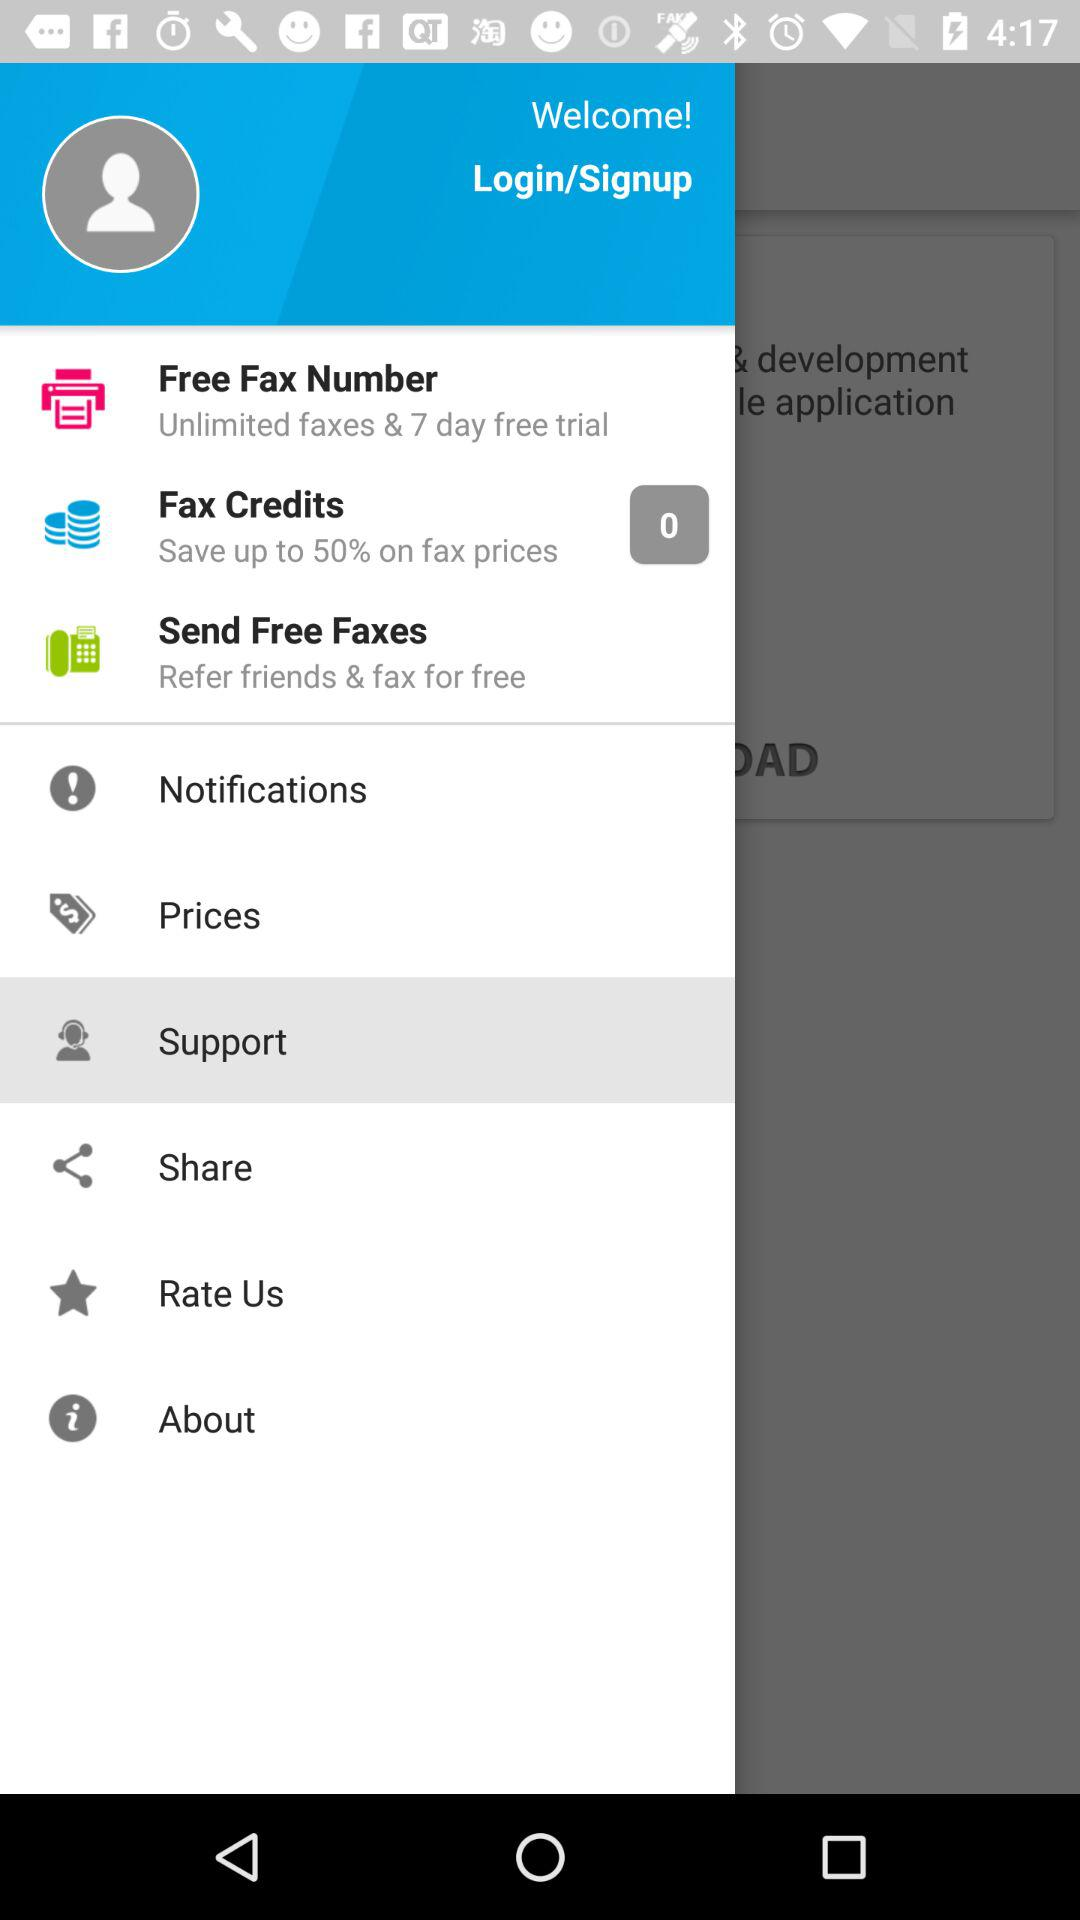Which option is selected? The selected option is "Support". 